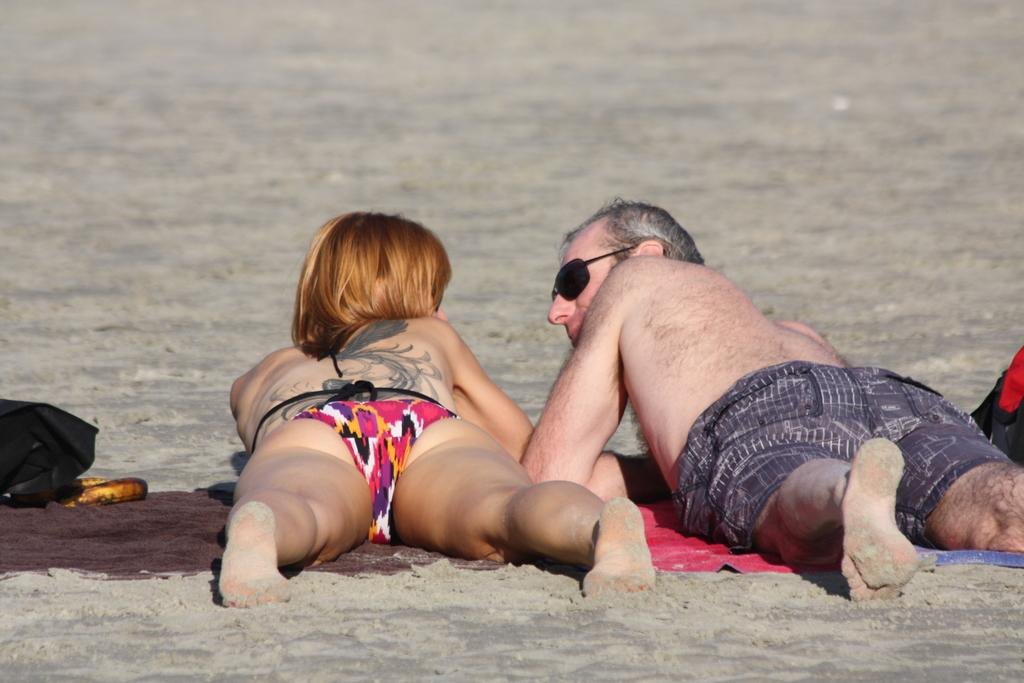How many people are present in the image? There are two people in the image, a woman and a man. What are the woman and the man doing in the image? The woman and the man are lying on a cloth placed on the ground. What direction are the woman and the man facing? The woman and the man are facing backwards. What can be seen towards the left side of the image? There is a bag towards the left side of the image. What type of coal is being used to fuel the society in the image? There is no mention of coal or society in the image; it features a woman and a man lying on a cloth with a bag nearby. 